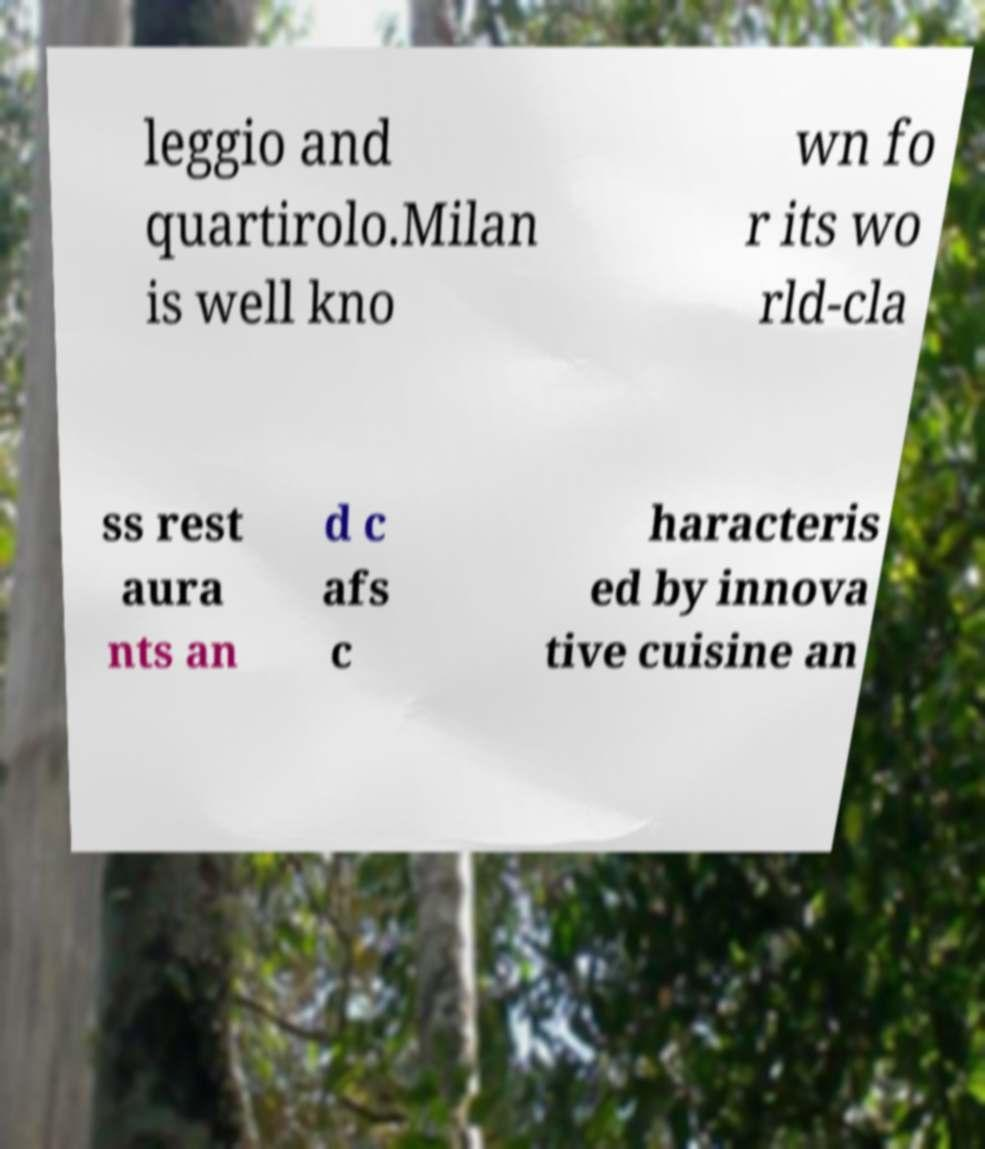Can you accurately transcribe the text from the provided image for me? leggio and quartirolo.Milan is well kno wn fo r its wo rld-cla ss rest aura nts an d c afs c haracteris ed by innova tive cuisine an 